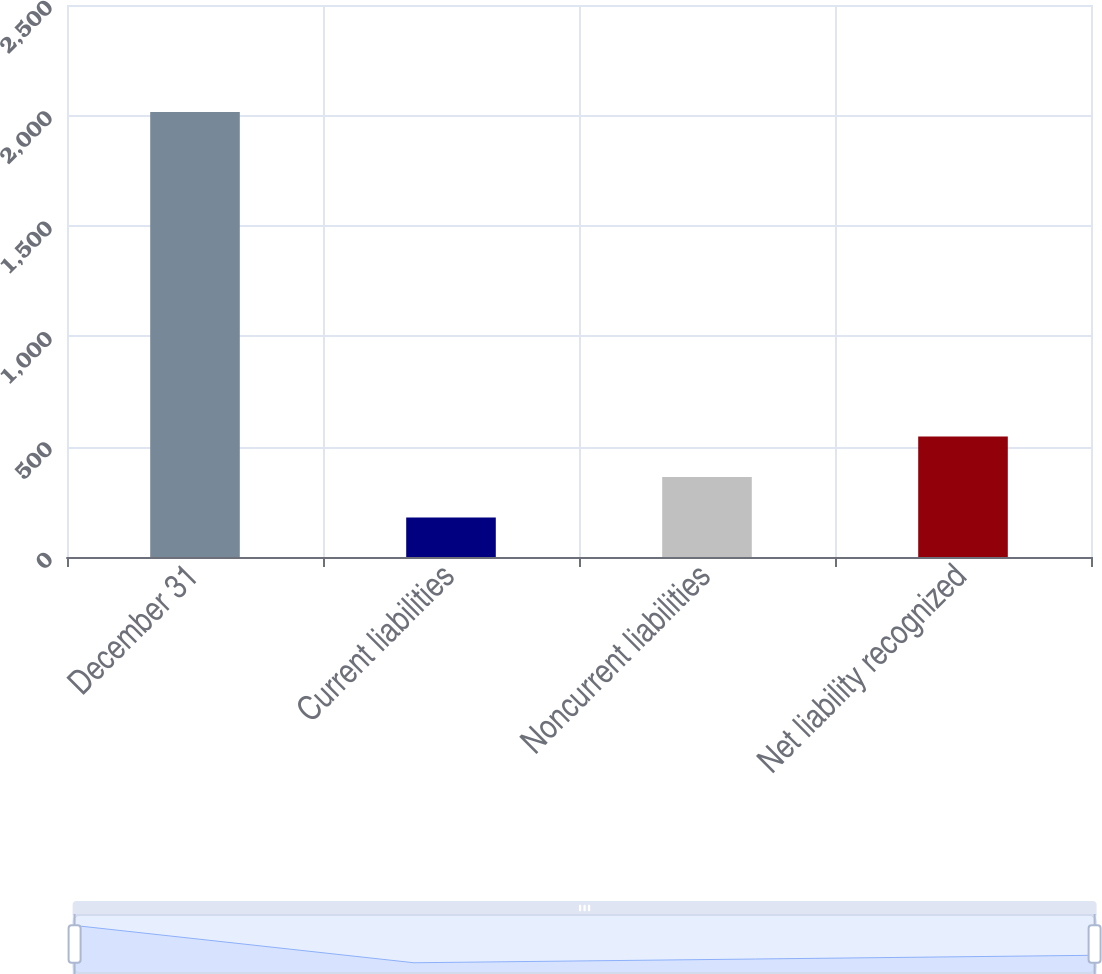<chart> <loc_0><loc_0><loc_500><loc_500><bar_chart><fcel>December 31<fcel>Current liabilities<fcel>Noncurrent liabilities<fcel>Net liability recognized<nl><fcel>2015<fcel>179<fcel>362.6<fcel>546.2<nl></chart> 